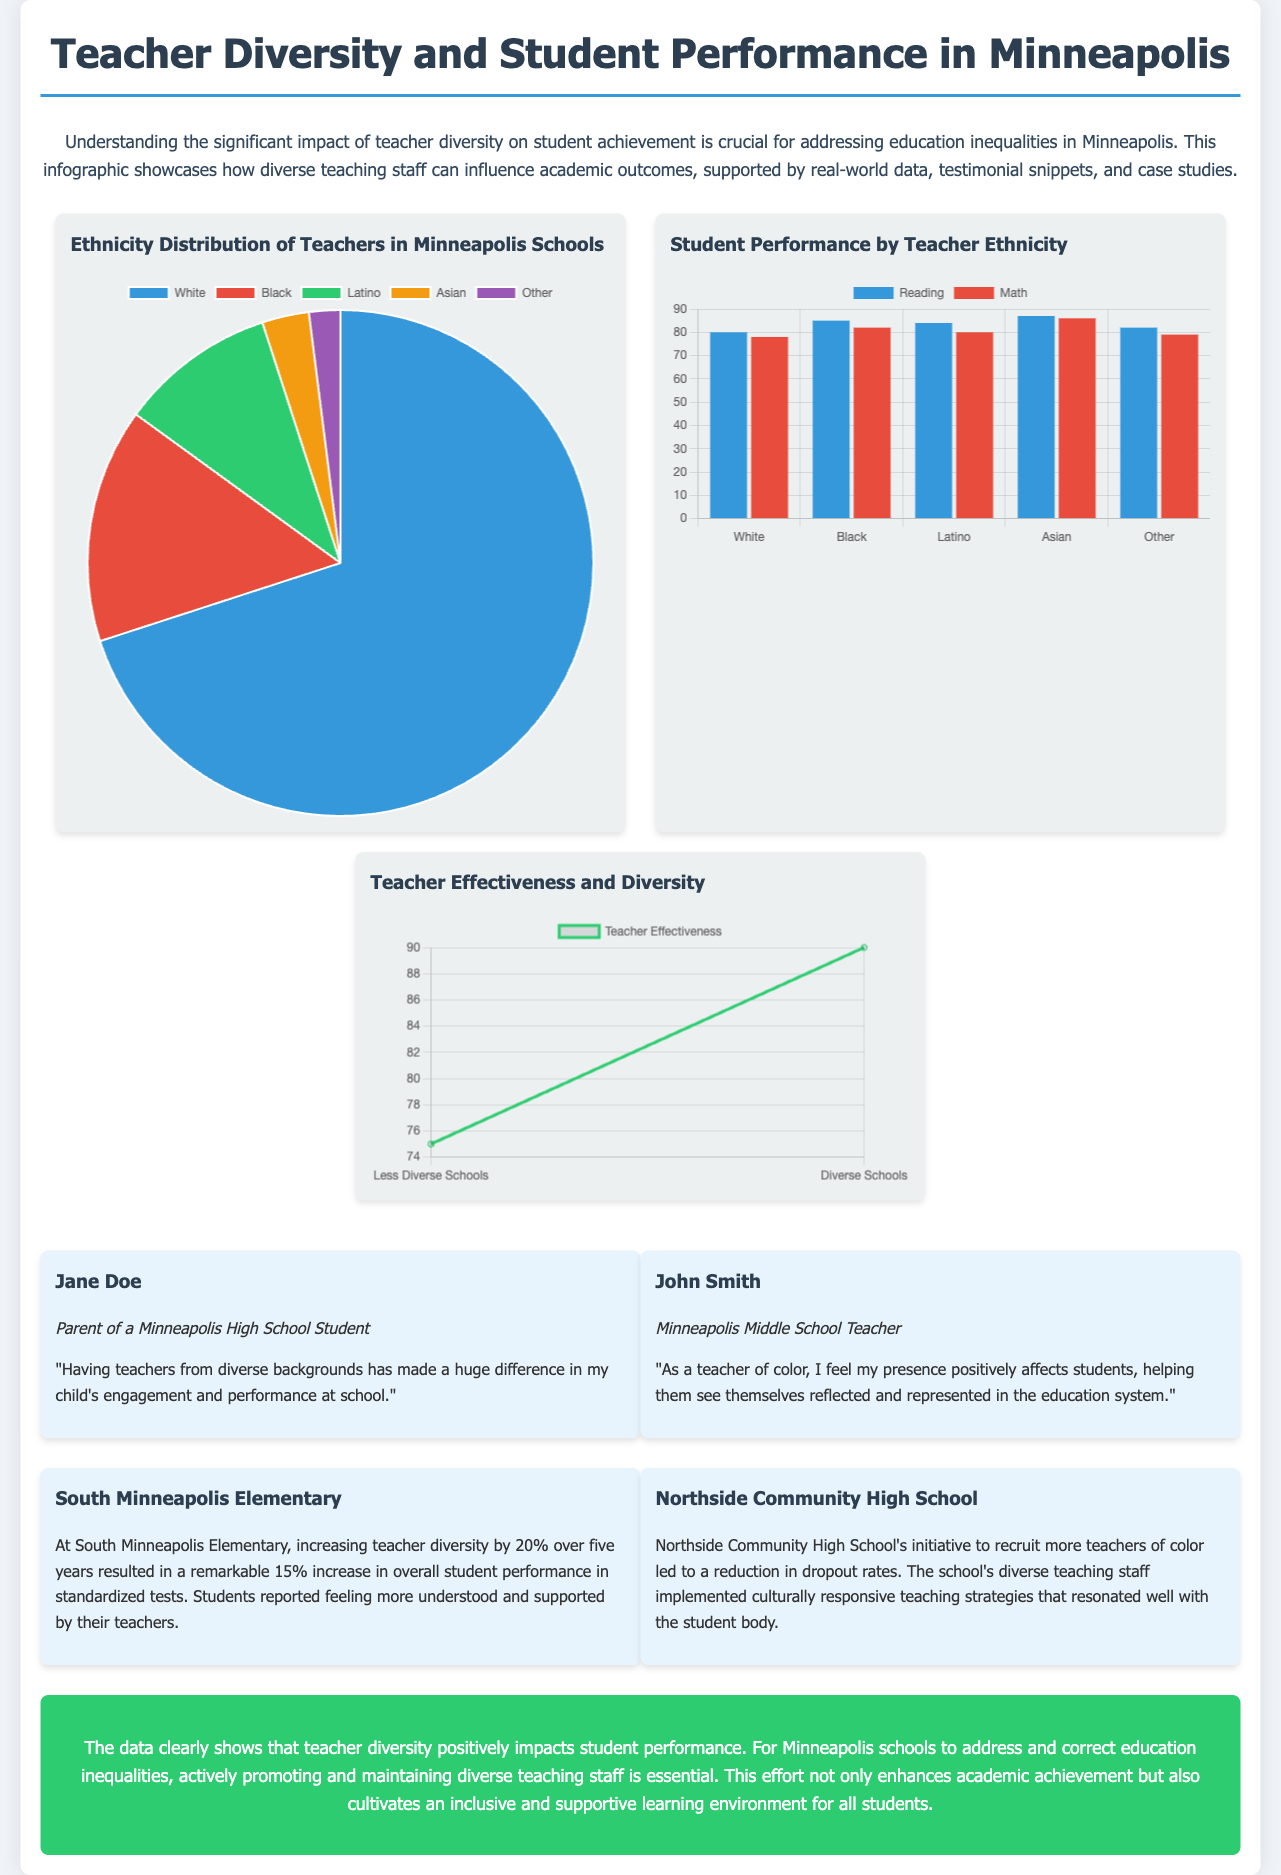What percentage of teachers are White in Minneapolis schools? The document states that 70% of teachers are White, as shown in the pie chart titled "Teacher Ethnicity Distribution."
Answer: 70% What is the increase in student performance at South Minneapolis Elementary after increasing teacher diversity? The text indicates that there was a 15% increase in overall student performance as a result of increasing teacher diversity by 20%.
Answer: 15% Which group of students has the highest average reading performance? According to the bar chart, Black students have the highest average reading performance at 85%.
Answer: Black How many types of ethnicities are represented in the teacher distribution chart? The chart shows five different ethnic groups: White, Black, Latino, Asian, and Other, indicating the variety present.
Answer: Five What was the impact on dropout rates at Northside Community High School after recruiting more teachers of color? The case study mentions that dropout rates were reduced due to the recruitment of teachers of color and the implementation of culturally responsive teaching strategies.
Answer: Reduced What is the effectiveness percentage of teachers in less diverse schools? The line graph indicates that the effectiveness percentage of teachers in less diverse schools is 75%.
Answer: 75% What is the primary conclusion drawn from the data presented in the infographic? The conclusion emphasizes that teacher diversity has a positive impact on student performance and is essential to address education inequalities.
Answer: Teacher diversity positively impacts student performance 